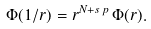<formula> <loc_0><loc_0><loc_500><loc_500>\Phi ( 1 / r ) = r ^ { N + s \, p } \, \Phi ( r ) .</formula> 